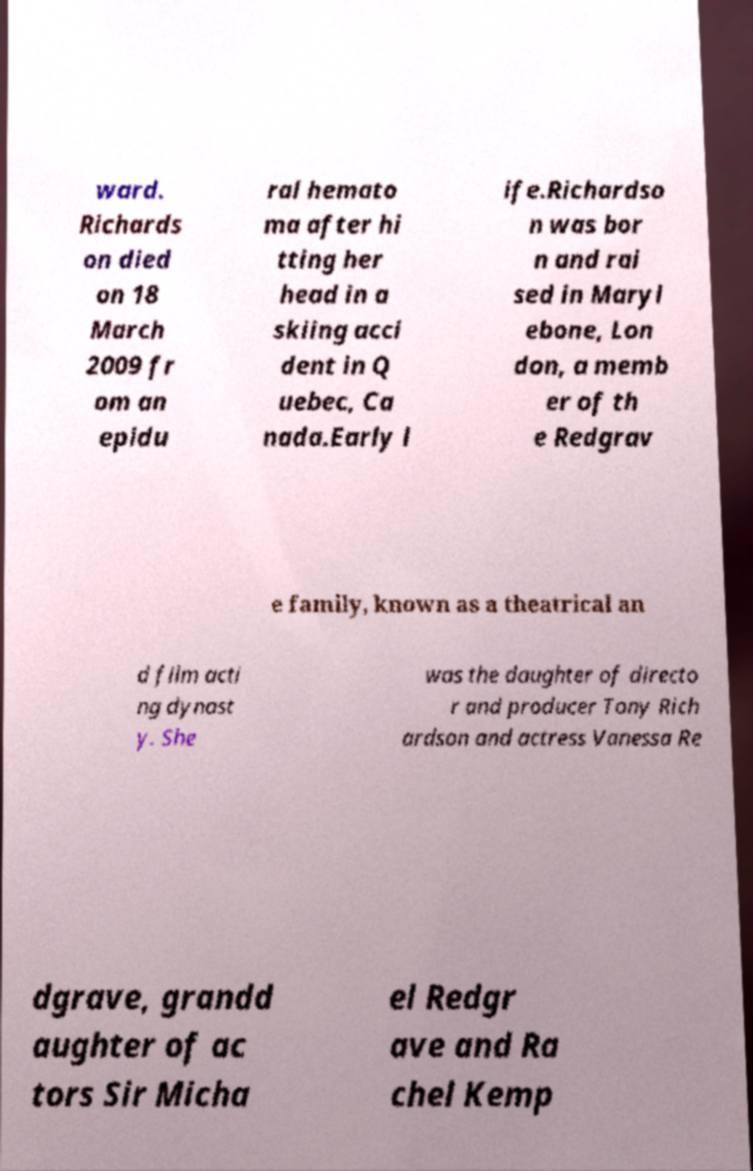I need the written content from this picture converted into text. Can you do that? ward. Richards on died on 18 March 2009 fr om an epidu ral hemato ma after hi tting her head in a skiing acci dent in Q uebec, Ca nada.Early l ife.Richardso n was bor n and rai sed in Maryl ebone, Lon don, a memb er of th e Redgrav e family, known as a theatrical an d film acti ng dynast y. She was the daughter of directo r and producer Tony Rich ardson and actress Vanessa Re dgrave, grandd aughter of ac tors Sir Micha el Redgr ave and Ra chel Kemp 